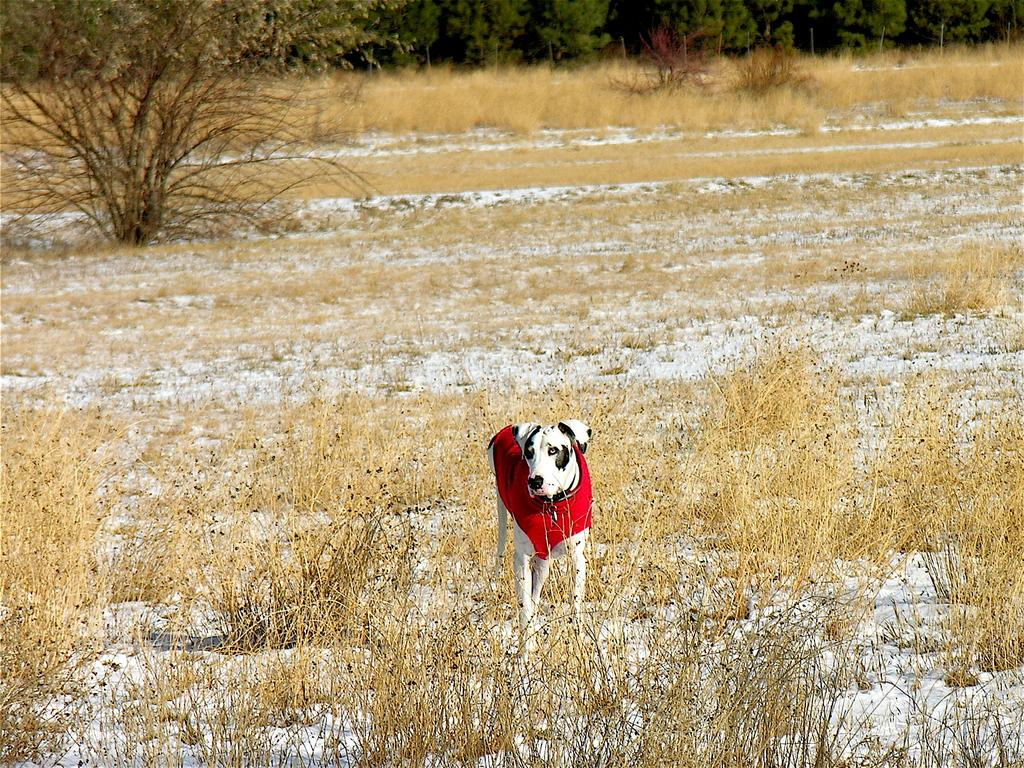What type of animal is in the image? There is a dog in the image. What is the dog wearing? The dog is wearing a red dress. What colors can be seen on the dog? The dog is white and black in color. What type of terrain is visible in the image? There is dry grass in the image. What other natural elements can be seen in the image? There are trees in the image. What type of structure is present in the image? There is fencing in the image. What type of mint is growing in the image? There is no mint present in the image; it features a dog wearing a red dress in a grassy area with trees and fencing. 